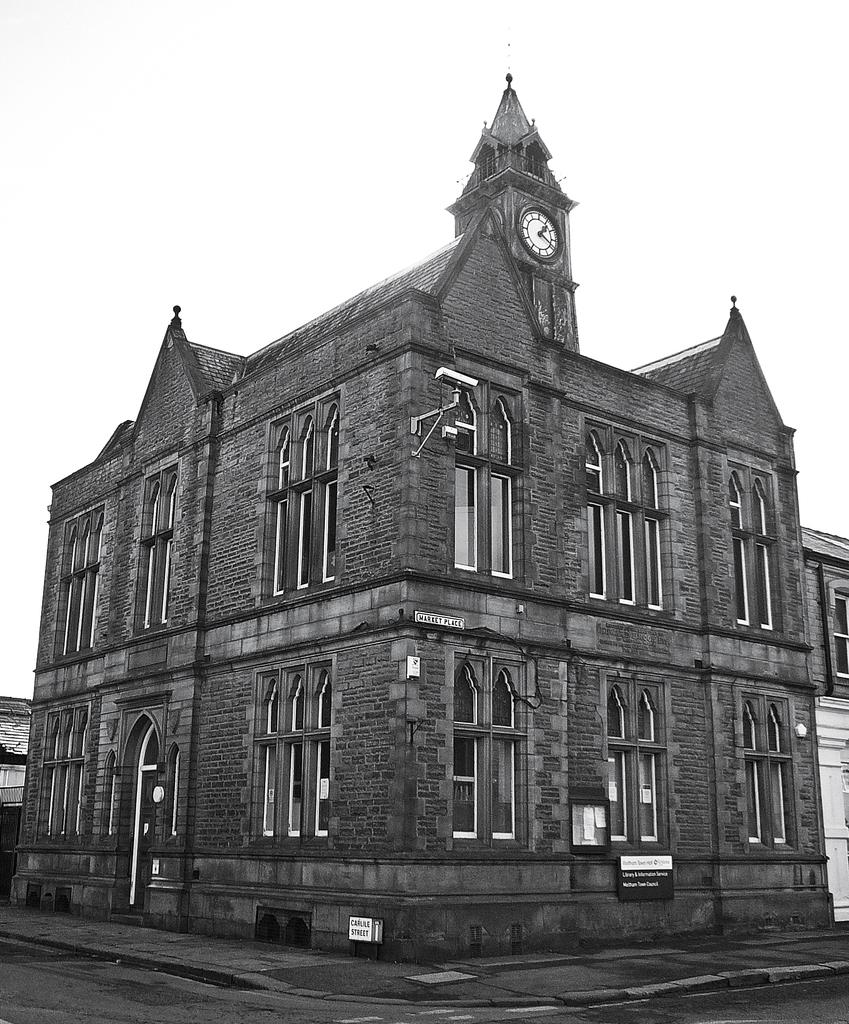What is the color scheme of the image? The image is black and white. What type of structure can be seen in the image? There is a building in the image. What specific feature is present on the building? There is a clock tower in the image. What can be seen in the background of the image? The sky is visible in the background of the image. What type of pancake is being served in the image? There is no pancake present in the image. Can you describe the picture hanging on the wall in the image? There is no mention of a picture hanging on the wall in the provided facts. 